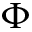<formula> <loc_0><loc_0><loc_500><loc_500>\Phi</formula> 